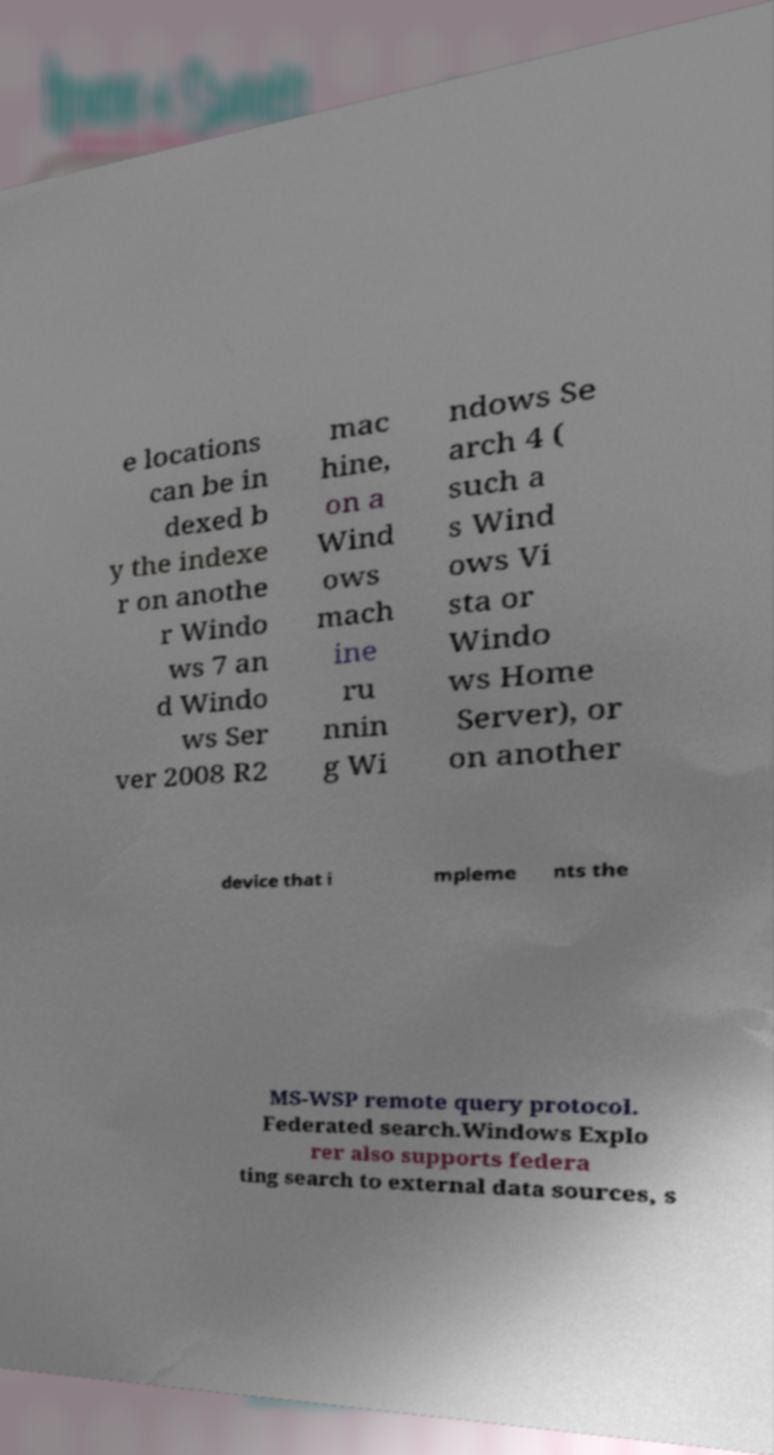Please identify and transcribe the text found in this image. e locations can be in dexed b y the indexe r on anothe r Windo ws 7 an d Windo ws Ser ver 2008 R2 mac hine, on a Wind ows mach ine ru nnin g Wi ndows Se arch 4 ( such a s Wind ows Vi sta or Windo ws Home Server), or on another device that i mpleme nts the MS-WSP remote query protocol. Federated search.Windows Explo rer also supports federa ting search to external data sources, s 